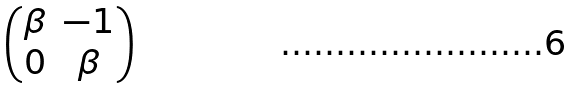Convert formula to latex. <formula><loc_0><loc_0><loc_500><loc_500>\begin{pmatrix} \beta & - 1 \\ 0 & \beta \end{pmatrix}</formula> 